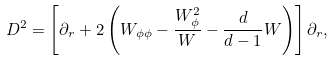<formula> <loc_0><loc_0><loc_500><loc_500>D ^ { 2 } = \left [ \partial _ { r } + 2 \left ( W _ { \phi \phi } - \frac { W _ { \phi } ^ { 2 } } { W } - \frac { d } { d - 1 } W \right ) \right ] \partial _ { r } ,</formula> 